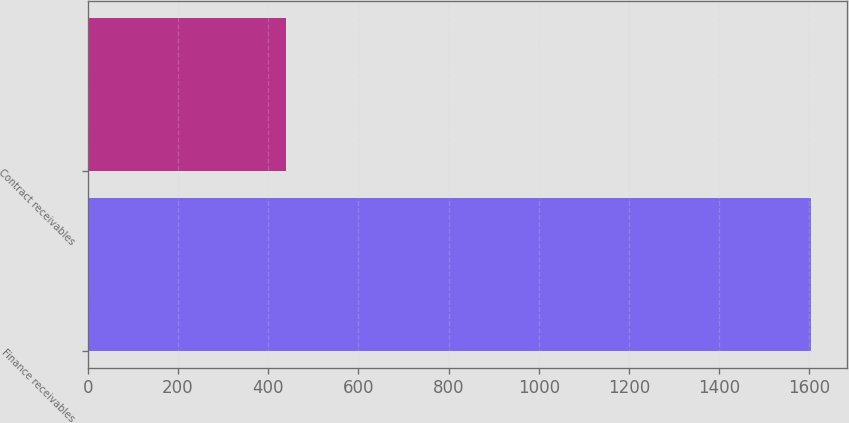Convert chart. <chart><loc_0><loc_0><loc_500><loc_500><bar_chart><fcel>Finance receivables<fcel>Contract receivables<nl><fcel>1602.5<fcel>439.4<nl></chart> 